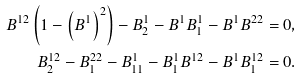Convert formula to latex. <formula><loc_0><loc_0><loc_500><loc_500>B ^ { 1 2 } \left ( 1 - \left ( B ^ { 1 } \right ) ^ { 2 } \right ) - B ^ { 1 } _ { 2 } - B ^ { 1 } B ^ { 1 } _ { 1 } - B ^ { 1 } B ^ { 2 2 } = 0 , \\ B ^ { 1 2 } _ { 2 } - B ^ { 2 2 } _ { 1 } - B ^ { 1 } _ { 1 1 } - B ^ { 1 } _ { 1 } B ^ { 1 2 } - B ^ { 1 } B ^ { 1 2 } _ { 1 } = 0 .</formula> 